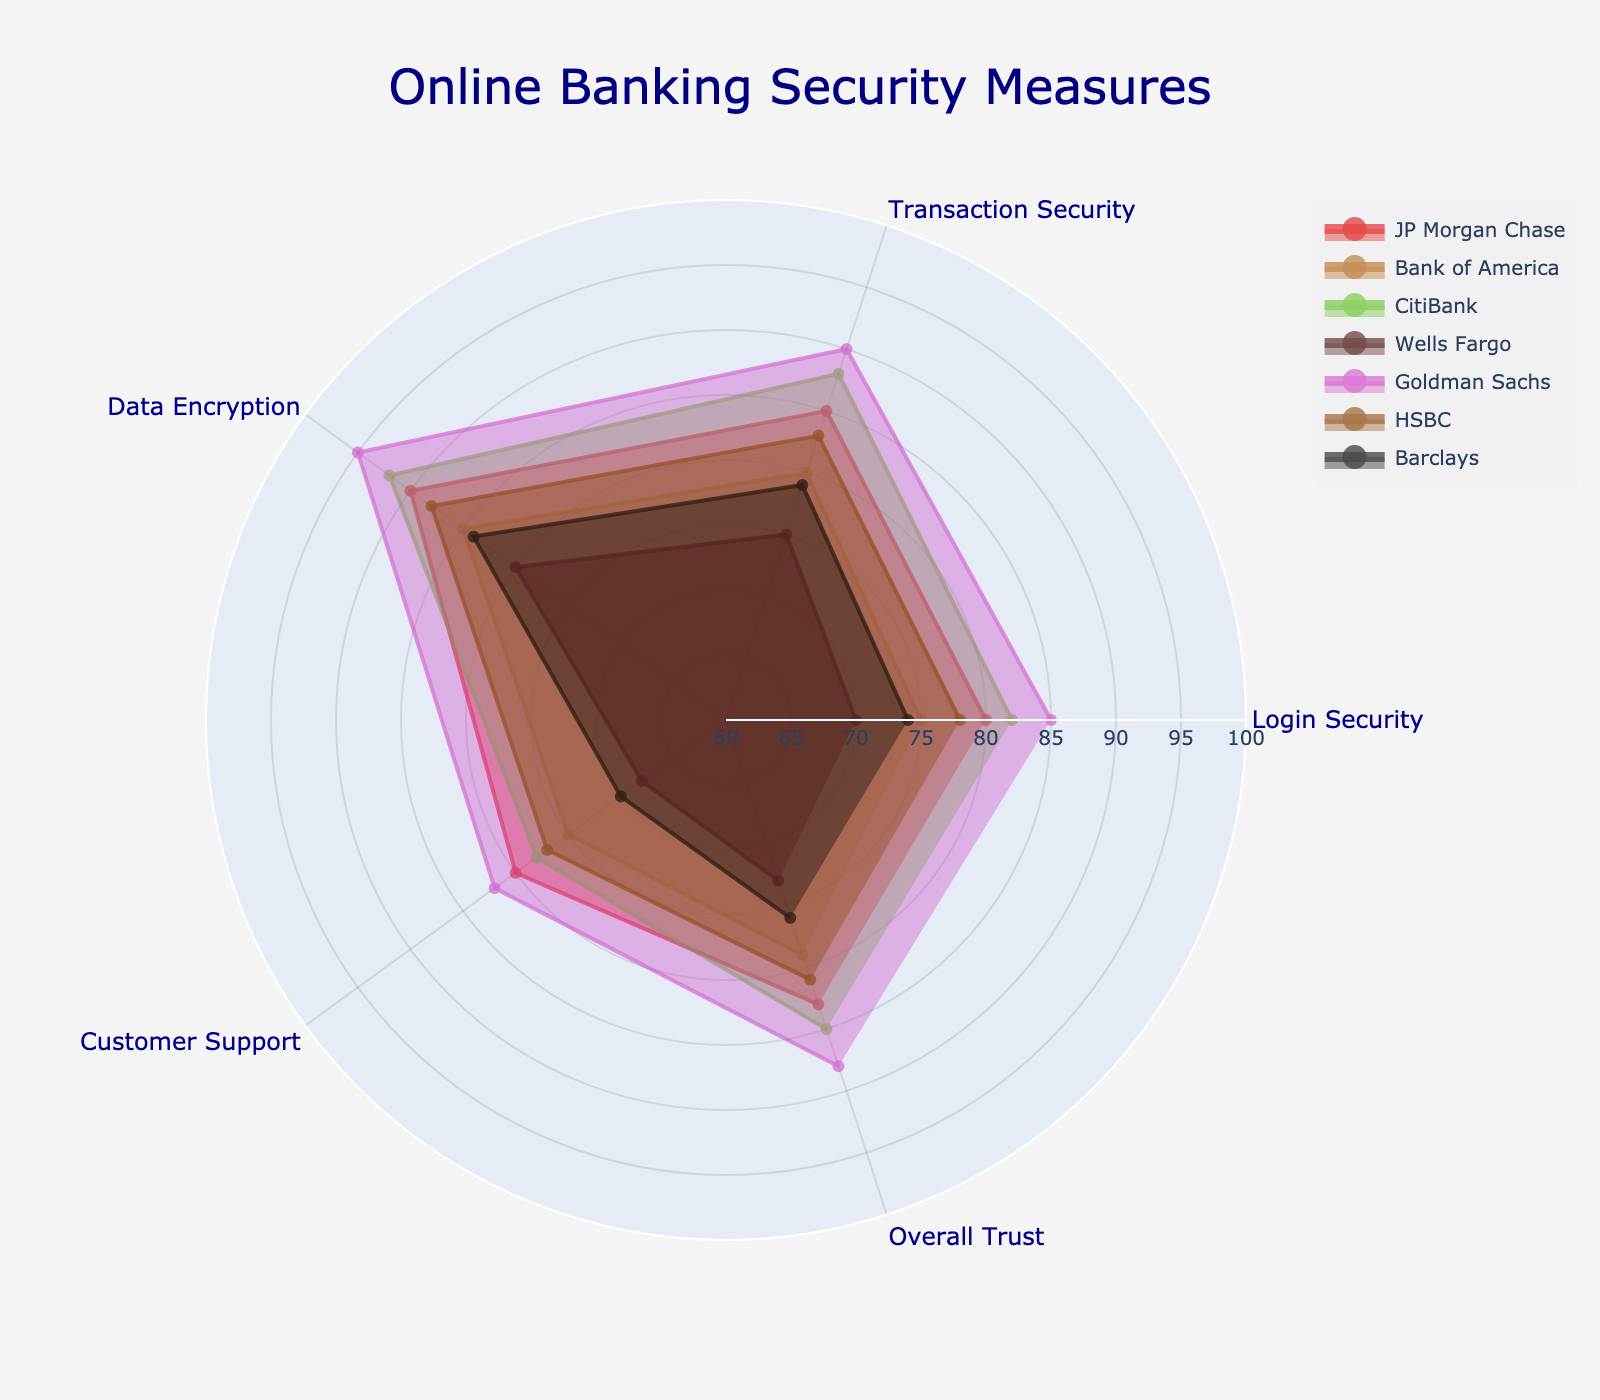How many banks have an "Overall Trust" score of 80 or above? Look at the "Overall Trust" axis and count the banks with values 80 or higher: JP Morgan Chase (83), CitiBank (85), Goldman Sachs (88), HSBC (81).
Answer: 4 Which bank has the highest score in "Data Encryption"? Identify the highest point on the "Data Encryption" axis. Goldman Sachs has the highest score of 95.
Answer: Goldman Sachs What's the average "Login Security" score across all banks? Sum the "Login Security" scores and divide by the number of banks: (80 + 75 + 82 + 70 + 85 + 78 + 74) / 7 = 544 / 7 = 77.71
Answer: 77.71 Which bank shows the greatest variability among its scores? Look at the spread of each bank's scores across all axes. Wells Fargo has a significant range from 68 to 80.
Answer: Wells Fargo Compare the "Customer Support" scores of JP Morgan Chase and HSBC. Which is higher? Locate the "Customer Support" values for both: JP Morgan Chase (80) and HSBC (77). JP Morgan Chase has a higher score.
Answer: JP Morgan Chase What is the average score for Goldman Sachs across all categories? Sum Goldman Sachs' scores and divide by the number of categories: (85 + 90 + 95 + 82 + 88) / 5 = 440 / 5 = 88
Answer: 88 Which bank has the lowest score in "Transaction Security"? Identify the lowest point on the "Transaction Security" axis. Wells Fargo has the lowest score of 75.
Answer: Wells Fargo What's the range of "Overall Trust" scores? Find the highest and lowest "Overall Trust" scores: 88 (Goldman Sachs), 73 (Wells Fargo). The range is 88 - 73 = 15.
Answer: 15 Which bank has the closest "Data Encryption" and "Transaction Security" scores? Compare the differences between "Data Encryption" and "Transaction Security" scores. CitiBank has similar scores of 92 and 88, respectively.
Answer: CitiBank What's the median "Login Security" score for the banks? Order the "Login Security" scores: 70, 74, 75, 78, 80, 82, 85. The median is the middle value, 78.
Answer: 78 